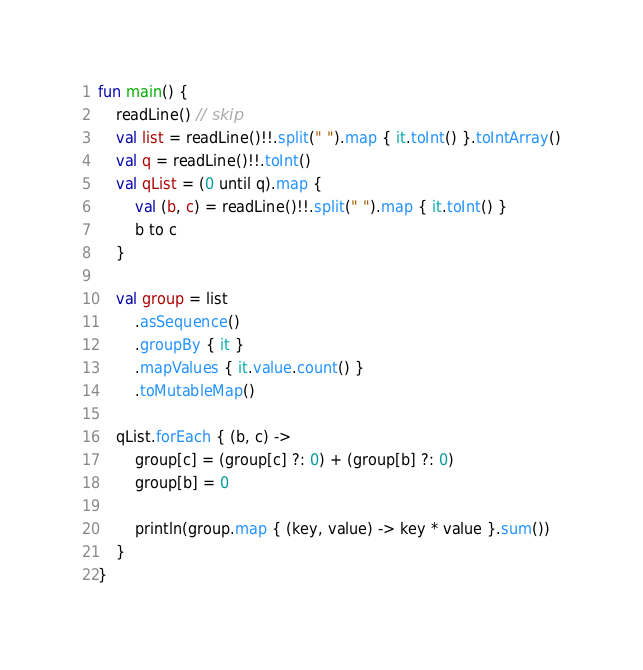Convert code to text. <code><loc_0><loc_0><loc_500><loc_500><_Kotlin_>fun main() {
    readLine() // skip
    val list = readLine()!!.split(" ").map { it.toInt() }.toIntArray()
    val q = readLine()!!.toInt()
    val qList = (0 until q).map {
        val (b, c) = readLine()!!.split(" ").map { it.toInt() }
        b to c
    }

    val group = list
        .asSequence()
        .groupBy { it }
        .mapValues { it.value.count() }
        .toMutableMap()

    qList.forEach { (b, c) ->
        group[c] = (group[c] ?: 0) + (group[b] ?: 0)
        group[b] = 0

        println(group.map { (key, value) -> key * value }.sum())
    }
}</code> 